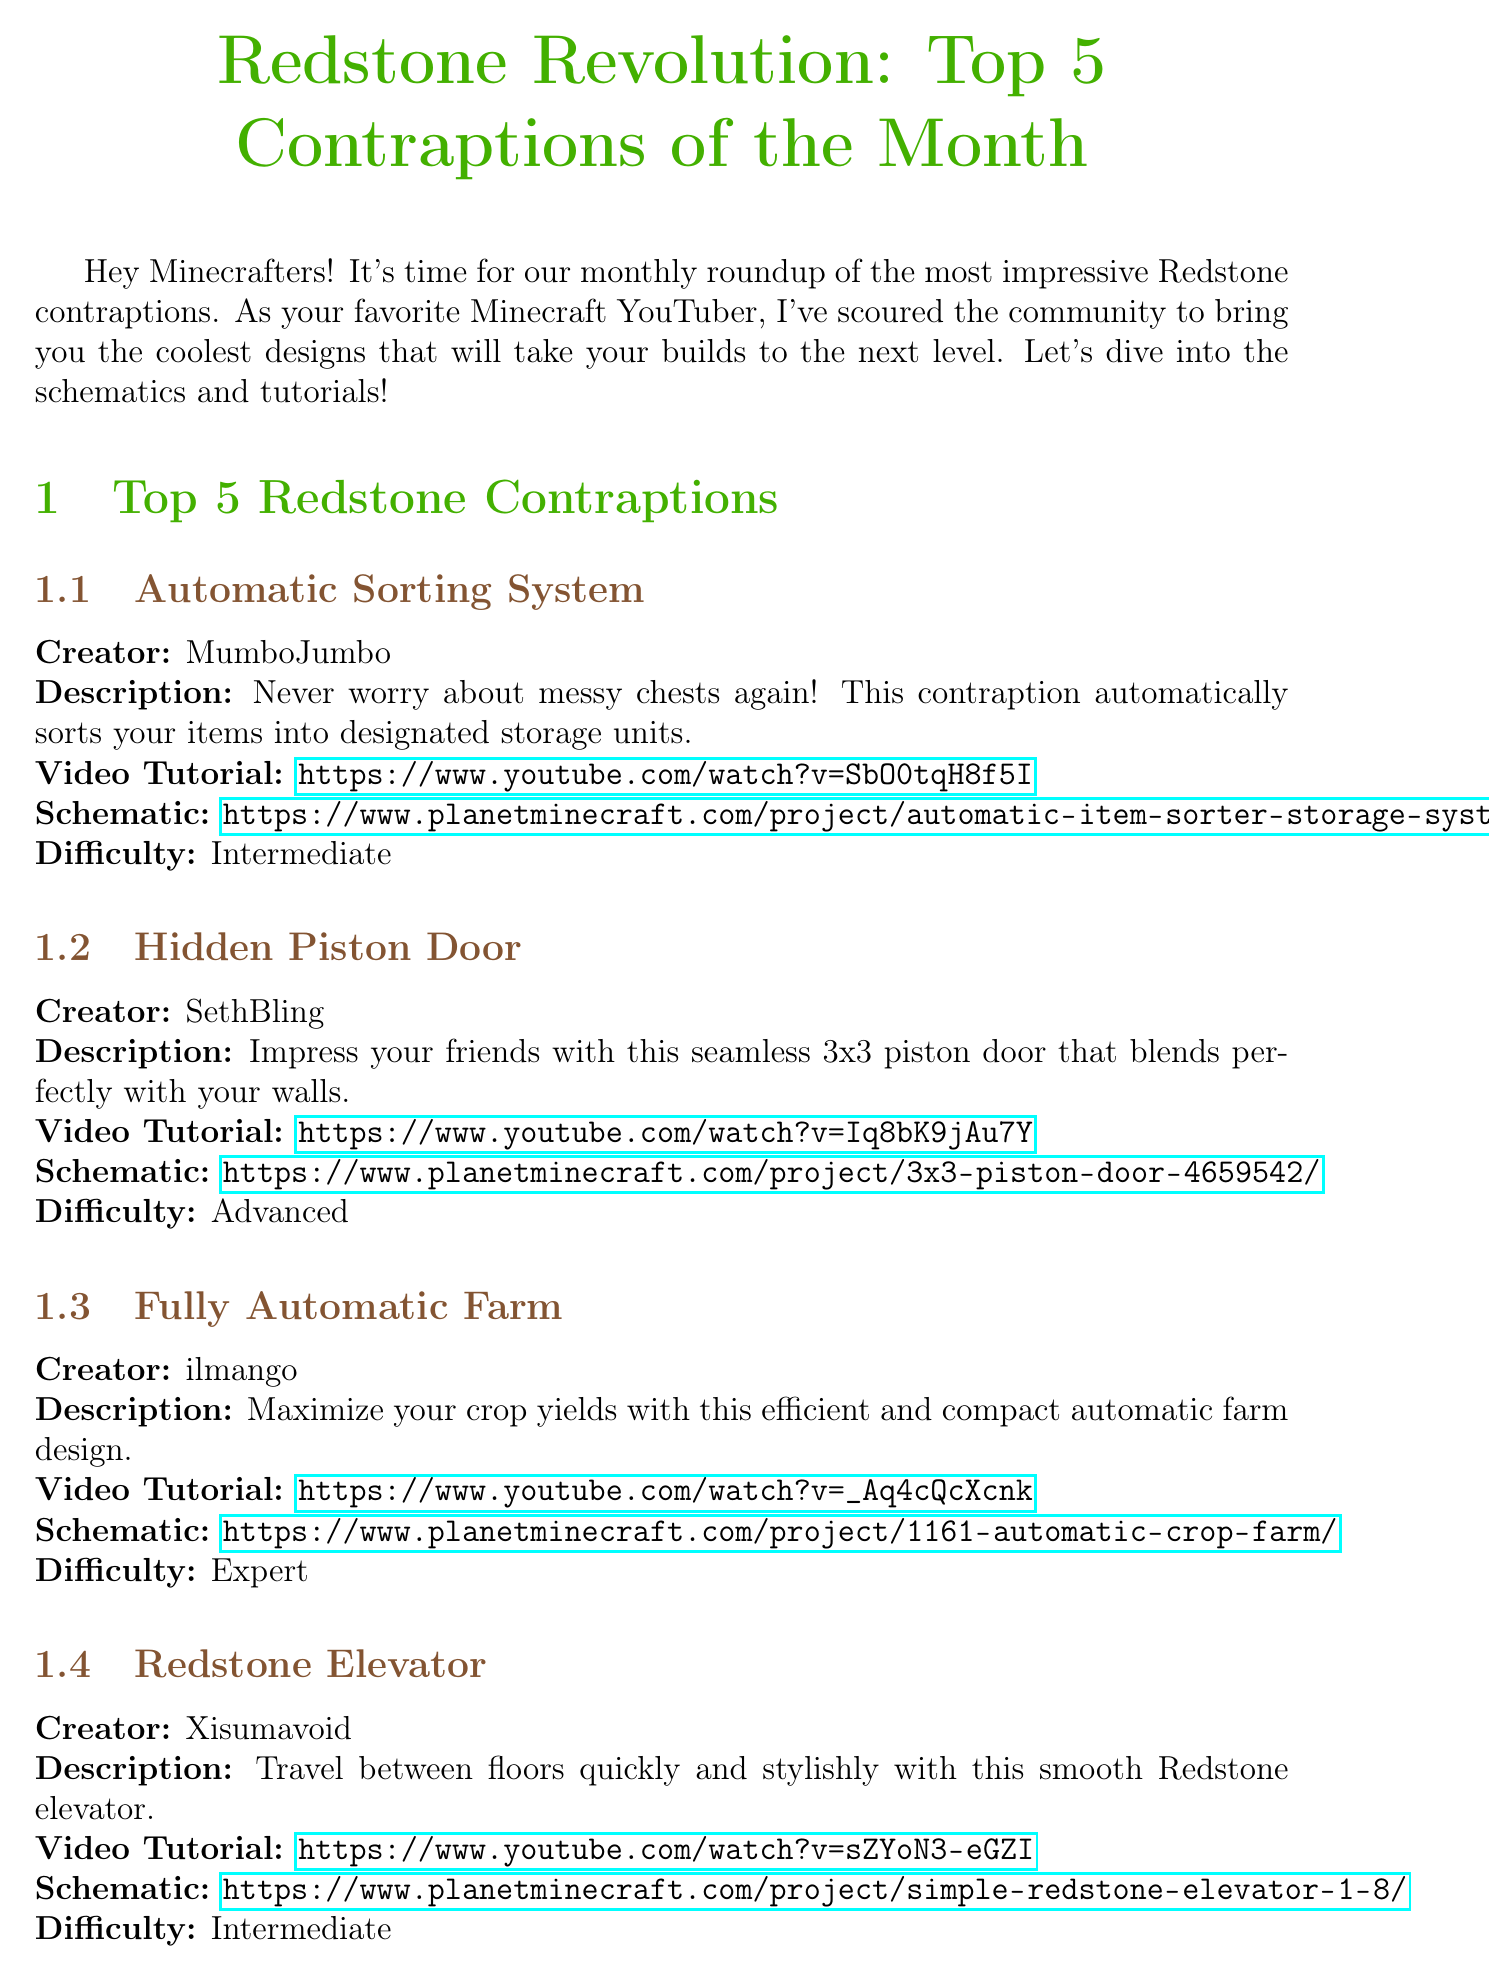What is the title of the newsletter? The title is stated at the top of the document, indicating the main topic of the newsletter.
Answer: Redstone Revolution: Top 5 Contraptions of the Month Who created the Automatic Sorting System? The document provides the creator's name alongside each contraption.
Answer: MumboJumbo What is the difficulty level of the Fully Automatic Farm? The difficulty levels are listed for each contraption, explaining how challenging they are to build.
Answer: Expert What is the submission deadline for the Redstone Challenge? The deadline for submissions is explicitly mentioned in the challenge section of the document.
Answer: May 31, 2023 Which contraption allows for seamless access between floors? The document describes each contraption, including their unique features and functionalities.
Answer: Redstone Elevator How many contraptions are featured in this newsletter? The introduction to the newsletter states that five contraptions are highlighted.
Answer: 5 What is the teaser for upcoming content? The upcoming content section provides details on what the viewers can expect in future videos.
Answer: Stay tuned for my upcoming video series.. Who is featured in the Community Spotlight? The Community Spotlight section highlights a specific achiever and their creation.
Answer: CaptainSparklez What type of contraption is the TNT Cannon used for? The description of each contraption mentions its purpose and context of use.
Answer: Siege warfare 